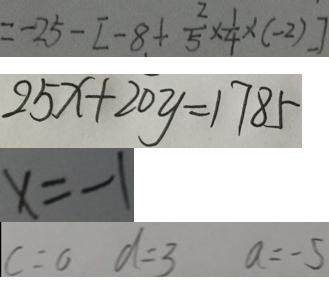Convert formula to latex. <formula><loc_0><loc_0><loc_500><loc_500>= - 2 5 - [ - 8 + \frac { 2 } { 5 } \times \frac { 1 } { 4 } \times ( - 2 ) ] 
 2 5 x + 2 0 y = 1 7 8 5 
 x = - 1 
 c = 0 d = 3 a = - 5</formula> 